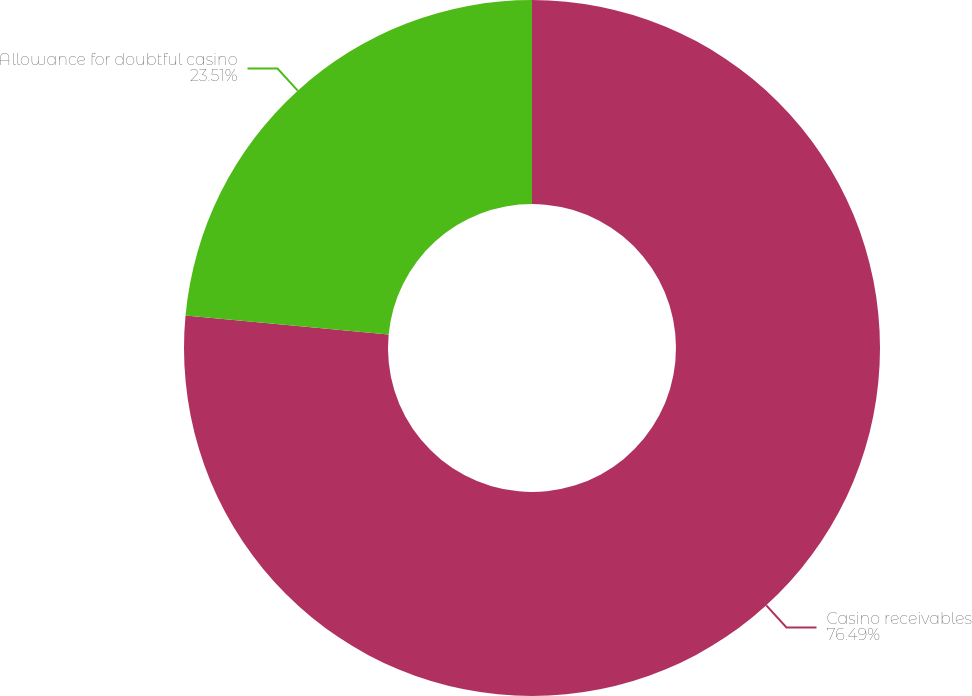<chart> <loc_0><loc_0><loc_500><loc_500><pie_chart><fcel>Casino receivables<fcel>Allowance for doubtful casino<nl><fcel>76.49%<fcel>23.51%<nl></chart> 